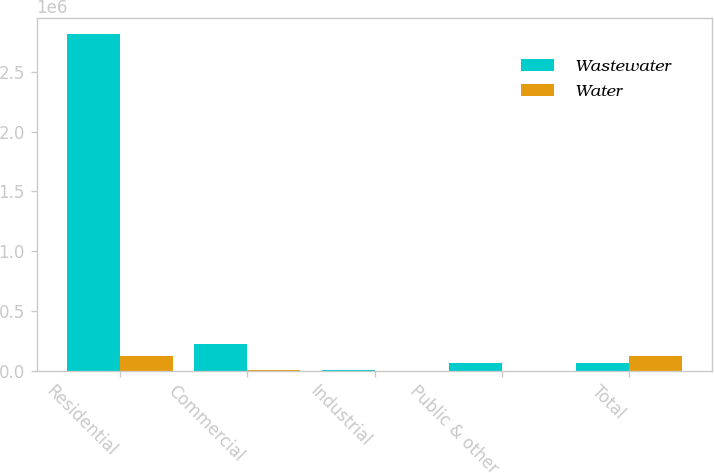Convert chart to OTSL. <chart><loc_0><loc_0><loc_500><loc_500><stacked_bar_chart><ecel><fcel>Residential<fcel>Commercial<fcel>Industrial<fcel>Public & other<fcel>Total<nl><fcel>Wastewater<fcel>2.81372e+06<fcel>218314<fcel>3793<fcel>59249<fcel>59249<nl><fcel>Water<fcel>117602<fcel>6221<fcel>17<fcel>281<fcel>124121<nl></chart> 